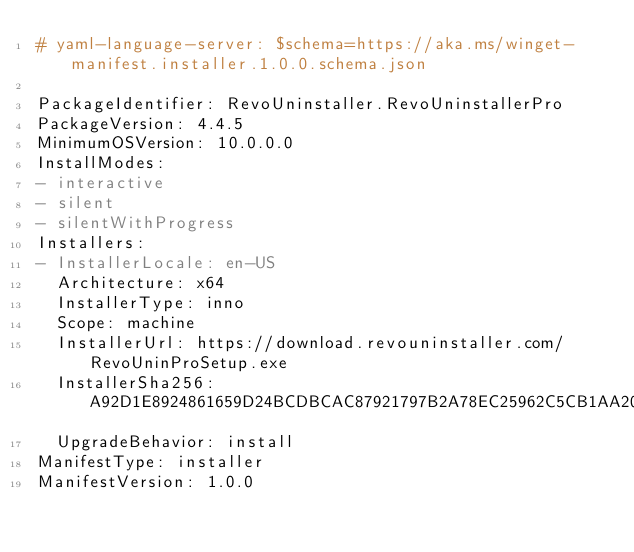<code> <loc_0><loc_0><loc_500><loc_500><_YAML_># yaml-language-server: $schema=https://aka.ms/winget-manifest.installer.1.0.0.schema.json

PackageIdentifier: RevoUninstaller.RevoUninstallerPro
PackageVersion: 4.4.5
MinimumOSVersion: 10.0.0.0
InstallModes:
- interactive
- silent
- silentWithProgress
Installers:
- InstallerLocale: en-US
  Architecture: x64
  InstallerType: inno
  Scope: machine
  InstallerUrl: https://download.revouninstaller.com/RevoUninProSetup.exe
  InstallerSha256: A92D1E8924861659D24BCDBCAC87921797B2A78EC25962C5CB1AA2052F2D71E9
  UpgradeBehavior: install
ManifestType: installer
ManifestVersion: 1.0.0

</code> 